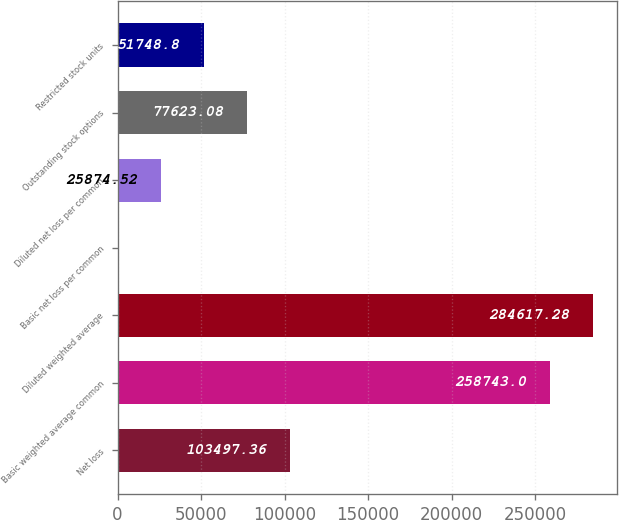Convert chart. <chart><loc_0><loc_0><loc_500><loc_500><bar_chart><fcel>Net loss<fcel>Basic weighted average common<fcel>Diluted weighted average<fcel>Basic net loss per common<fcel>Diluted net loss per common<fcel>Outstanding stock options<fcel>Restricted stock units<nl><fcel>103497<fcel>258743<fcel>284617<fcel>0.24<fcel>25874.5<fcel>77623.1<fcel>51748.8<nl></chart> 